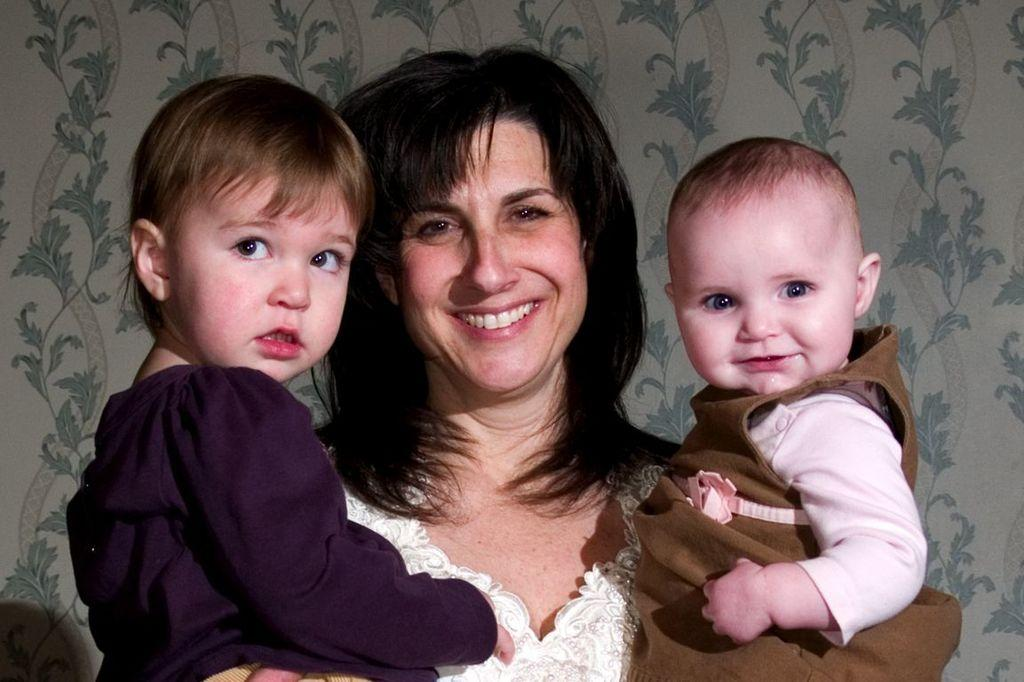Who is the main subject in the image? There is a woman in the image. What is the woman doing in the image? The woman is standing and smiling. What is the woman holding in her hands? The woman is holding two kids in her hands. What can be seen in the background of the image? There is a wall with a design in the background of the image. Can you see any coils or harbors in the image? No, there are no coils or harbors present in the image. Is there a drain visible in the image? No, there is no drain visible in the image. 